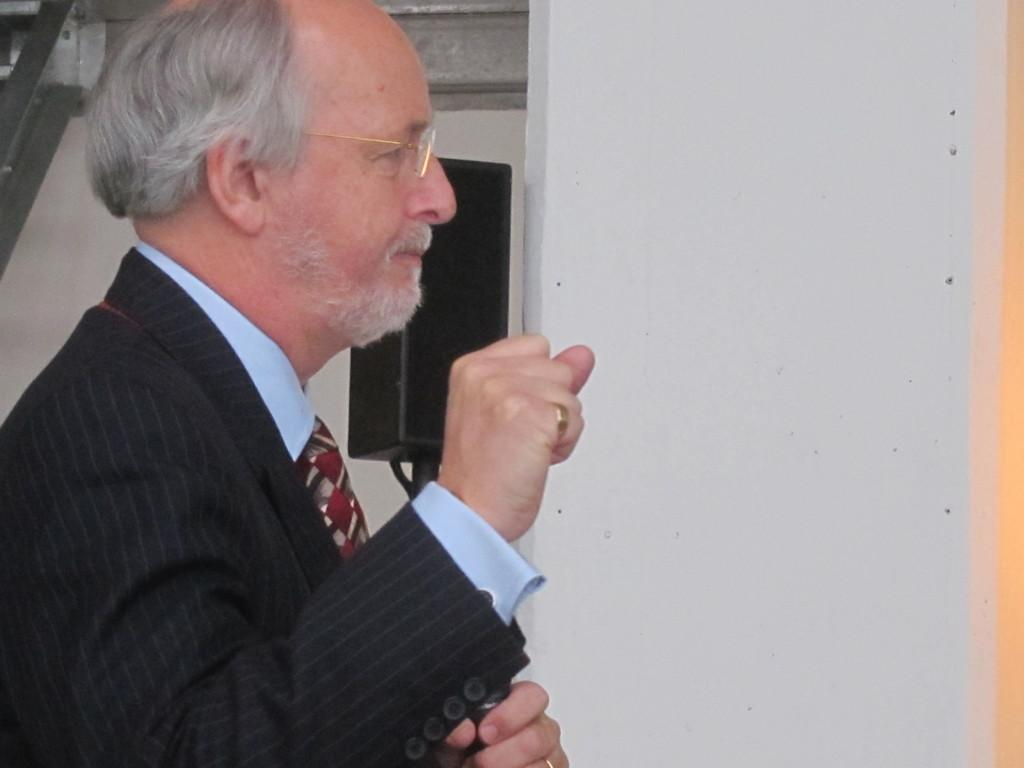What is the main subject of the image? There is an old man standing in the image. Can you describe the old man's appearance? The old man is wearing glasses. What color is the wall in the background of the image? The wall in the background of the image is white. What object can be seen in the image that is related to sound? There is a black color speaker in the image. Reasoning: Let' Let's think step by step in order to produce the conversation. We start by identifying the main subject of the image, which is the old man. Then, we describe a specific detail about the old man's appearance, which is that he is wearing glasses. Next, we mention the color of the wall in the background, which is white. Finally, we identify an object in the image that is related to sound, which is the black color speaker. Absurd Question/Answer: What type of necklace is the old man wearing in the image? There is no mention of a necklace in the provided facts, so it cannot be determined from the image. 